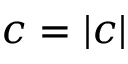<formula> <loc_0><loc_0><loc_500><loc_500>c = | c |</formula> 